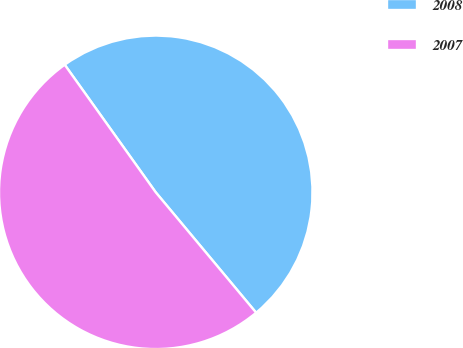Convert chart to OTSL. <chart><loc_0><loc_0><loc_500><loc_500><pie_chart><fcel>2008<fcel>2007<nl><fcel>48.8%<fcel>51.2%<nl></chart> 